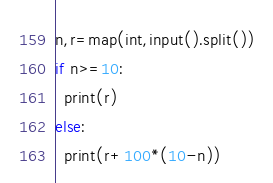Convert code to text. <code><loc_0><loc_0><loc_500><loc_500><_Python_>n,r=map(int,input().split())
if n>=10:
  print(r)
else:
  print(r+100*(10-n))
</code> 